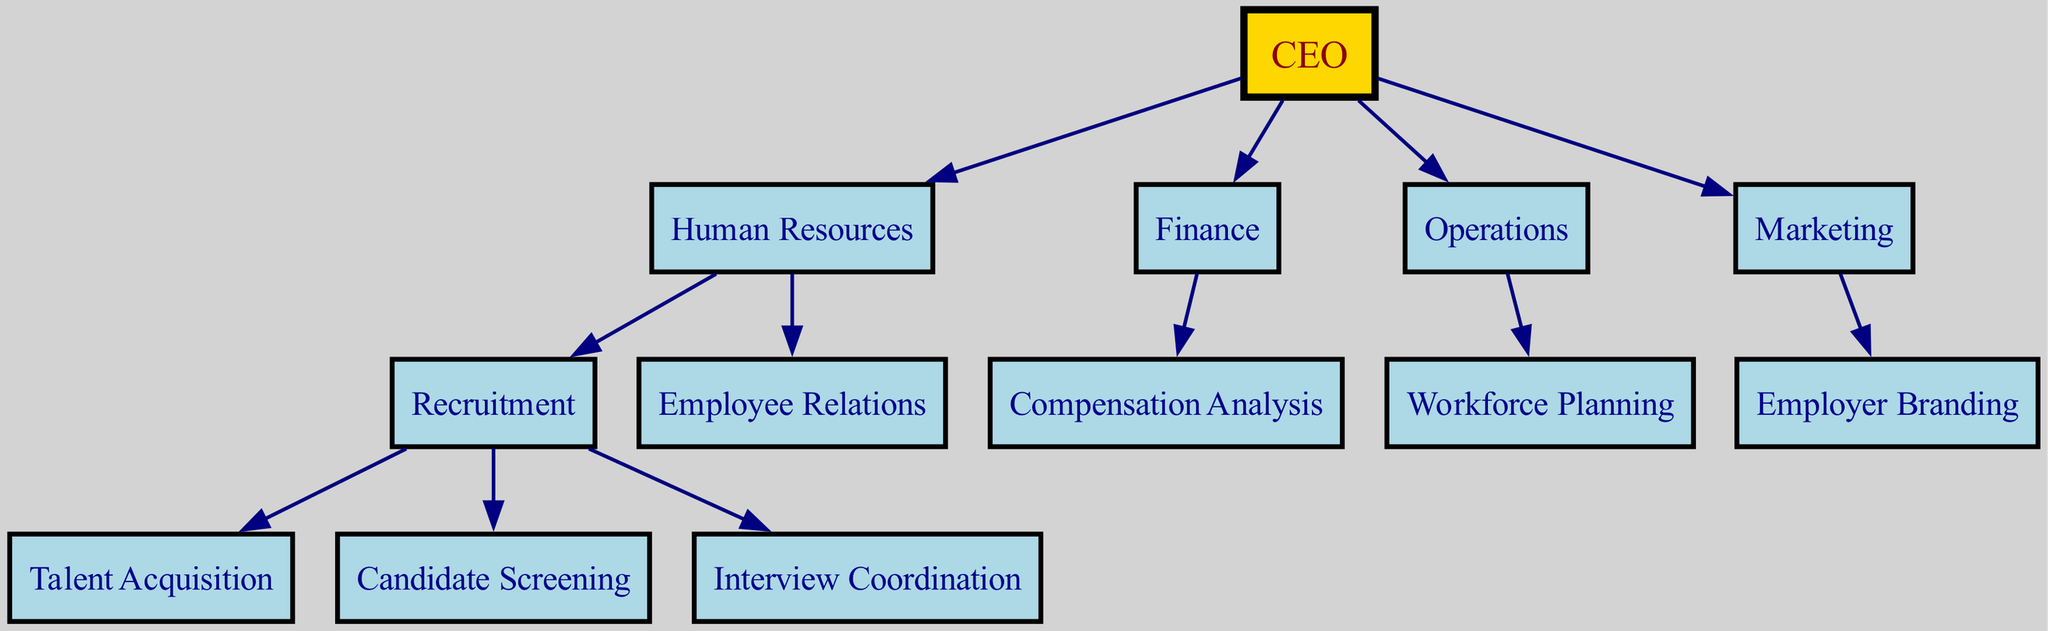What is the top node in the organizational chart? The top node, also known as the root, is labeled as "CEO". It is the highest point in the hierarchy.
Answer: CEO How many departments report directly to the Human Resources department? Human Resources has two departments directly beneath it: Recruitment and Employee Relations. This can be confirmed by counting the children of the Human Resources node.
Answer: 2 What is the relationship between Recruitment and Talent Acquisition? Talent Acquisition is a child or sub-department of the Recruitment department, meaning it falls directly under Recruitment in the hierarchy.
Answer: Child How many total divisions are present in the organizational chart? There are five divisions in total: CEO, Human Resources, Finance, Operations, and Marketing. This can be verified by counting the root division and the immediate child divisions.
Answer: 5 Which department is responsible for Compensation Analysis? Compensation Analysis is a sub-department under the Finance department, as indicated by its position in the chart.
Answer: Finance What is the total number of recruitment roles listed under the Recruitment department? There are three roles listed: Talent Acquisition, Candidate Screening, and Interview Coordination. This is determined by counting the children of the Recruitment node.
Answer: 3 Name a role that falls under the Operations department. The role listed under Operations is Workforce Planning. This is directly depicted under the Operations node.
Answer: Workforce Planning Which department is directly above Candidate Screening? The department directly above Candidate Screening is Recruitment, as it is a child node of Recruitment in the hierarchy.
Answer: Recruitment Is the Marketing department involved in recruitment activities? No, the Marketing department is focused on Employer Branding, which does not relate directly to recruitment activities.
Answer: No 